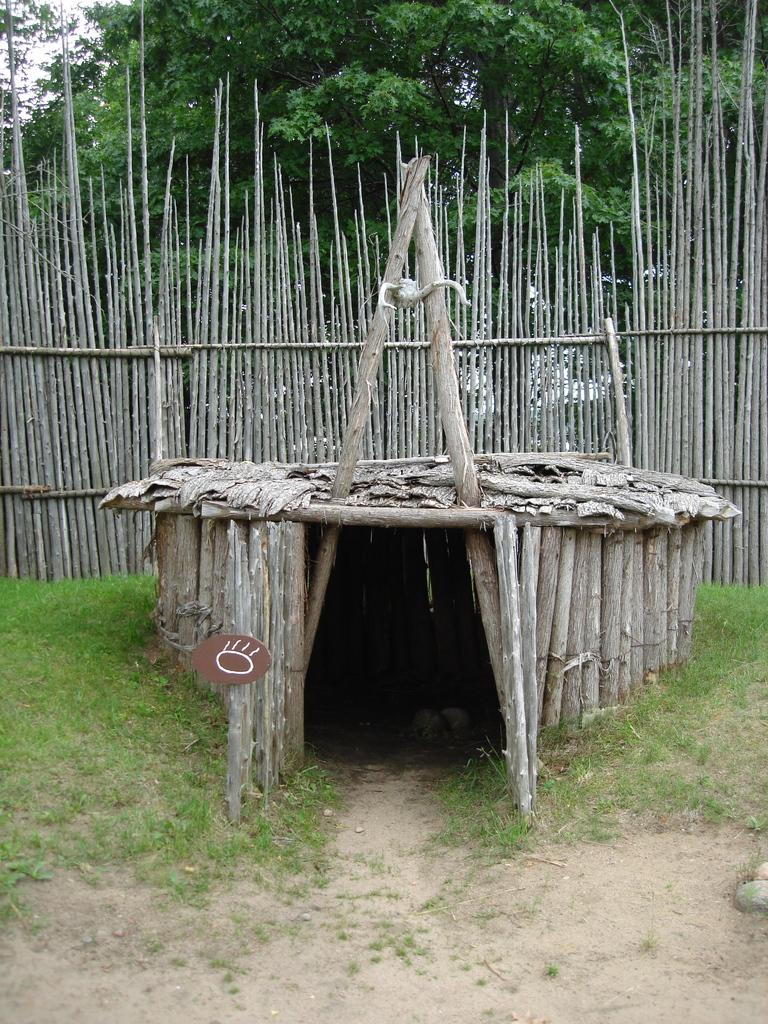What structure is made with wooden sticks in the image? There is a shed made with wooden sticks in the image. What type of ground is visible in the image? There is grass on the ground in the image. What can be seen in the background of the image? There is a wooden wall and trees present in the background of the image. Are there any soldiers wearing masks in the image? There are no soldiers or masks present in the image. How many hens can be seen in the image? There are no hens present in the image. 